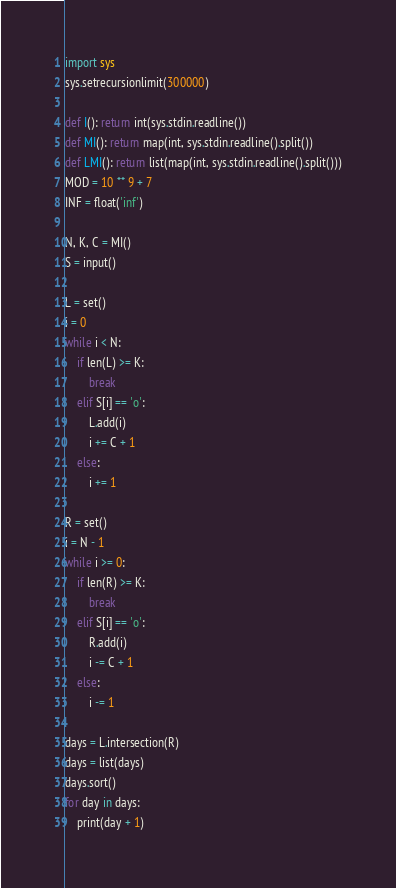<code> <loc_0><loc_0><loc_500><loc_500><_Python_>import sys
sys.setrecursionlimit(300000)

def I(): return int(sys.stdin.readline())
def MI(): return map(int, sys.stdin.readline().split())
def LMI(): return list(map(int, sys.stdin.readline().split()))
MOD = 10 ** 9 + 7
INF = float('inf')

N, K, C = MI()
S = input()

L = set()
i = 0
while i < N:
    if len(L) >= K:
        break
    elif S[i] == 'o':
        L.add(i)
        i += C + 1
    else:
        i += 1

R = set()
i = N - 1
while i >= 0:
    if len(R) >= K:
        break
    elif S[i] == 'o':
        R.add(i)
        i -= C + 1
    else:
        i -= 1

days = L.intersection(R)
days = list(days)
days.sort()
for day in days:
    print(day + 1)
</code> 